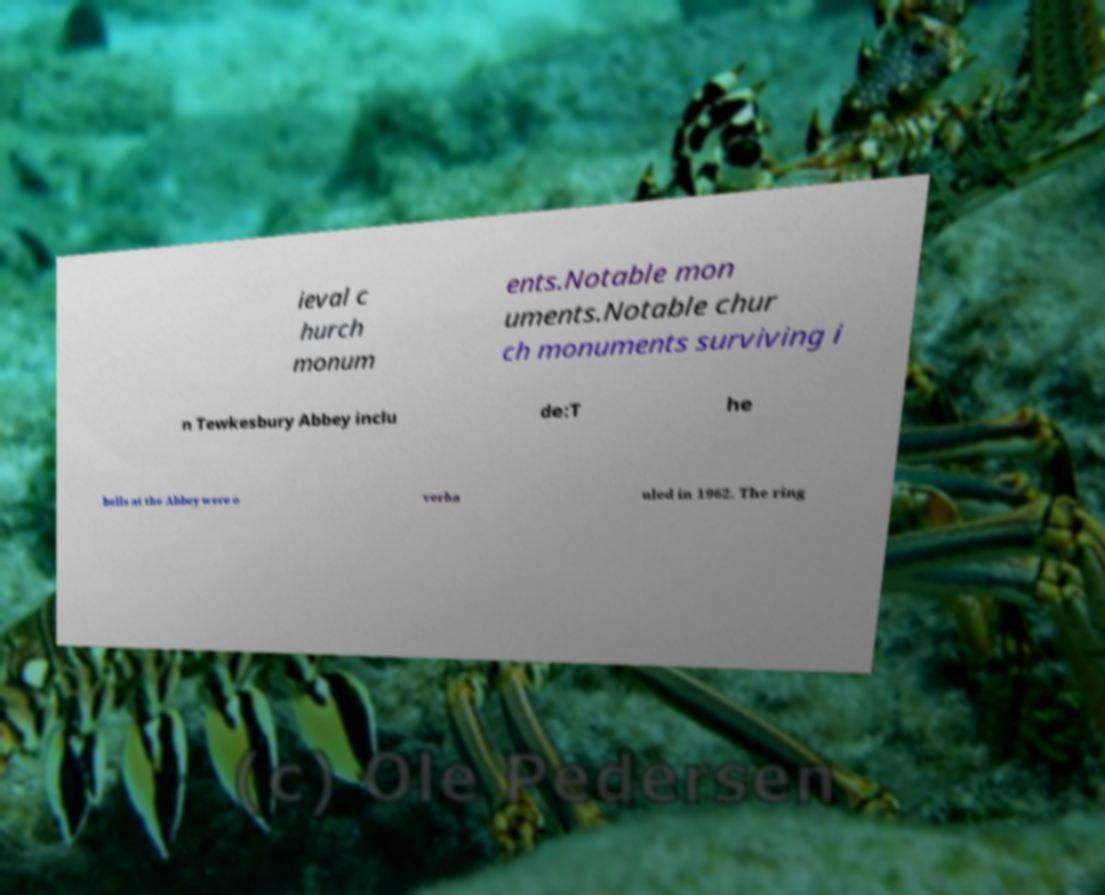Please identify and transcribe the text found in this image. ieval c hurch monum ents.Notable mon uments.Notable chur ch monuments surviving i n Tewkesbury Abbey inclu de:T he bells at the Abbey were o verha uled in 1962. The ring 